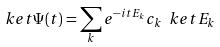Convert formula to latex. <formula><loc_0><loc_0><loc_500><loc_500>\ k e t { \Psi ( t ) } = \sum _ { k } e ^ { - i t E _ { k } } c _ { k } \ k e t { E _ { k } }</formula> 